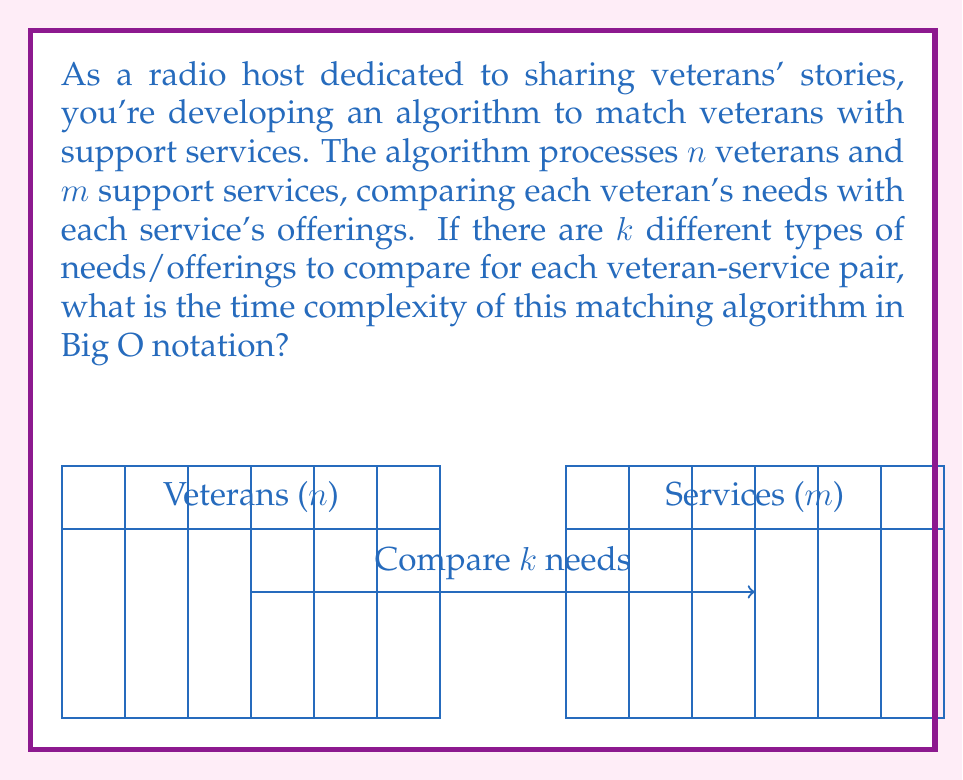Teach me how to tackle this problem. Let's break down the algorithm's runtime analysis step-by-step:

1) For each veteran (total $n$), the algorithm needs to compare with each support service (total $m$).
   This creates a nested loop structure.

2) For each veteran-service pair, the algorithm compares $k$ different types of needs/offerings.

3) The structure of the algorithm can be represented as:

   ```
   for each veteran (n times):
     for each service (m times):
       for each need type (k times):
         compare need with offering
   ```

4) This creates a triple nested loop structure.

5) The total number of comparisons (operations) performed is:
   $n \times m \times k$

6) In Big O notation, we focus on the growth rate with respect to the input size.
   Here, we have three variables: $n$, $m$, and $k$.

7) Assuming all three can grow independently, we express the time complexity as:
   $O(nmk)$

This represents the worst-case time complexity of the algorithm.
Answer: $O(nmk)$ 